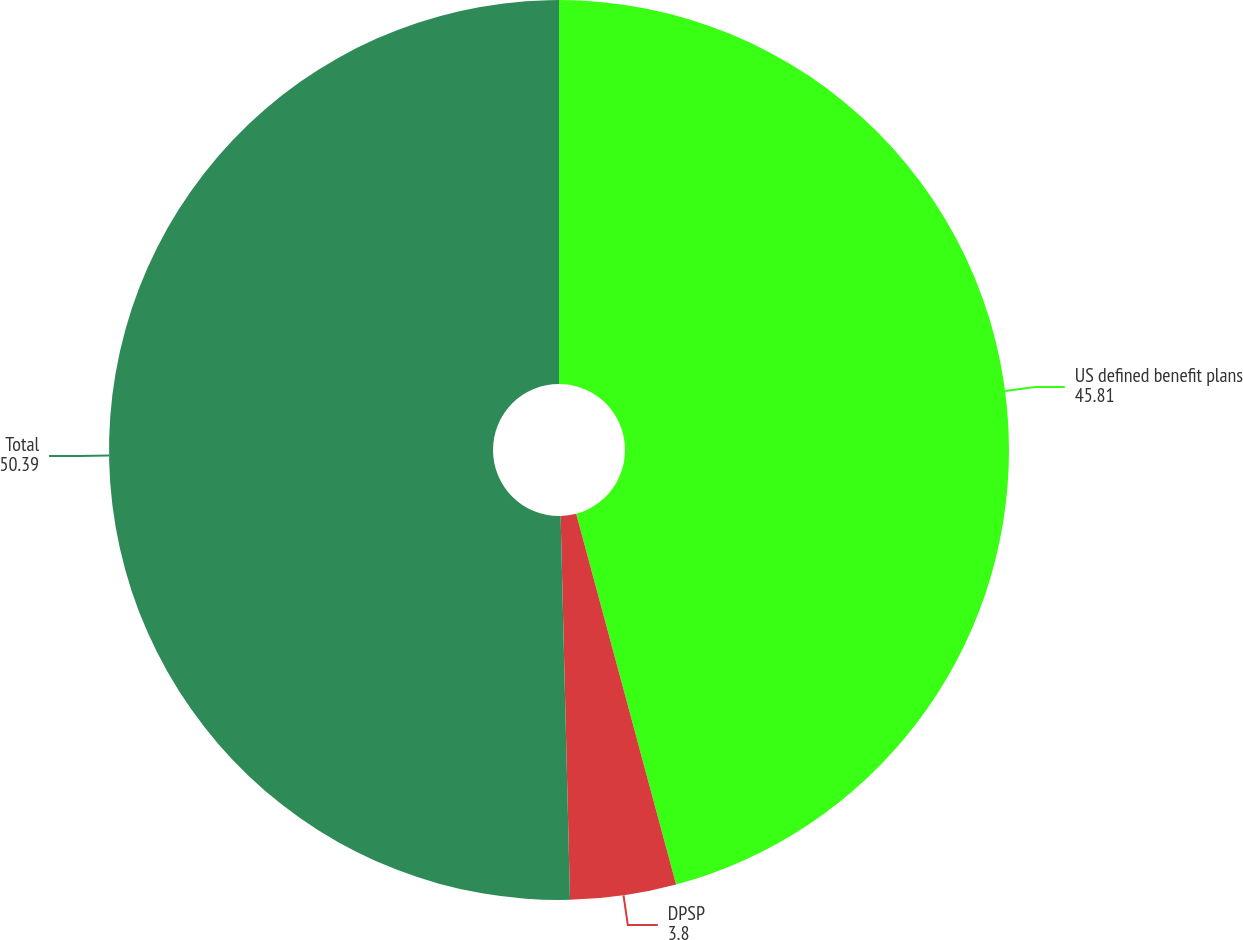<chart> <loc_0><loc_0><loc_500><loc_500><pie_chart><fcel>US defined benefit plans<fcel>DPSP<fcel>Total<nl><fcel>45.81%<fcel>3.8%<fcel>50.39%<nl></chart> 